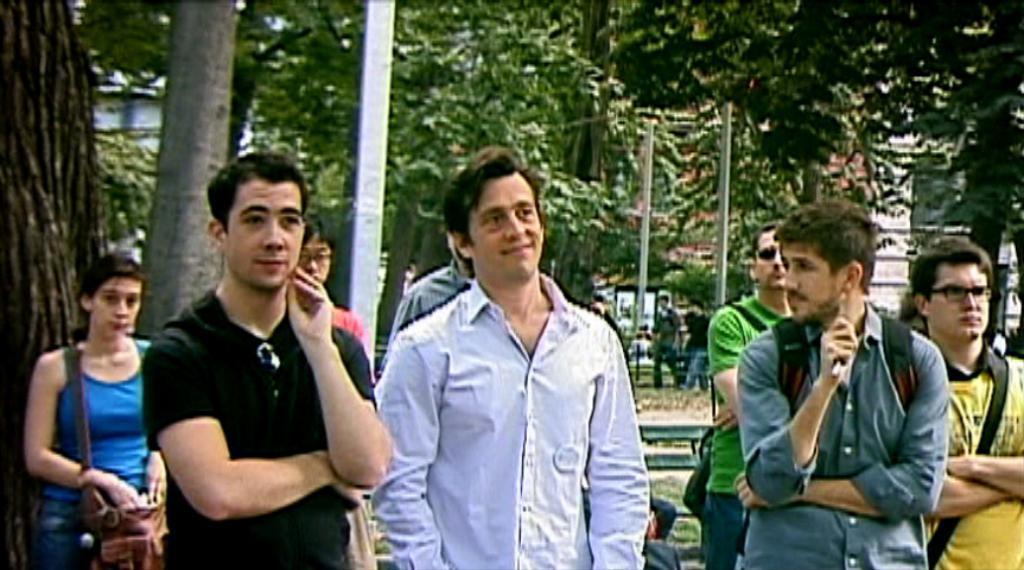In one or two sentences, can you explain what this image depicts? In the picture I can see people are standing on the ground. In the background I can see trees, poles and some other things. 